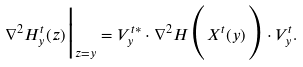<formula> <loc_0><loc_0><loc_500><loc_500>\nabla ^ { 2 } H ^ { t } _ { y } ( z ) \Big | _ { z = y } = V ^ { t * } _ { y } \cdot \nabla ^ { 2 } H \Big ( X ^ { t } ( y ) \Big ) \cdot V ^ { t } _ { y } .</formula> 